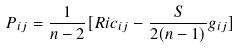Convert formula to latex. <formula><loc_0><loc_0><loc_500><loc_500>P _ { i j } = \frac { 1 } { n - 2 } [ R i c _ { i j } - \frac { S } { 2 ( n - 1 ) } g _ { i j } ]</formula> 